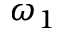<formula> <loc_0><loc_0><loc_500><loc_500>\omega _ { 1 }</formula> 